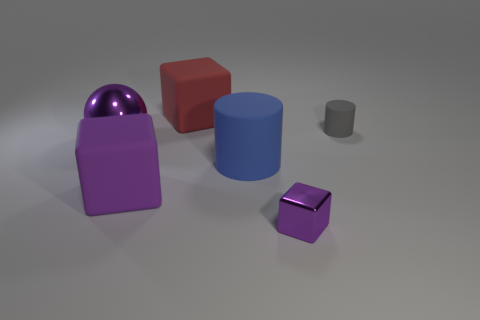Add 2 small blue shiny cylinders. How many objects exist? 8 Subtract all balls. How many objects are left? 5 Subtract 0 green spheres. How many objects are left? 6 Subtract all blue matte cylinders. Subtract all big matte things. How many objects are left? 2 Add 6 cubes. How many cubes are left? 9 Add 4 purple cubes. How many purple cubes exist? 6 